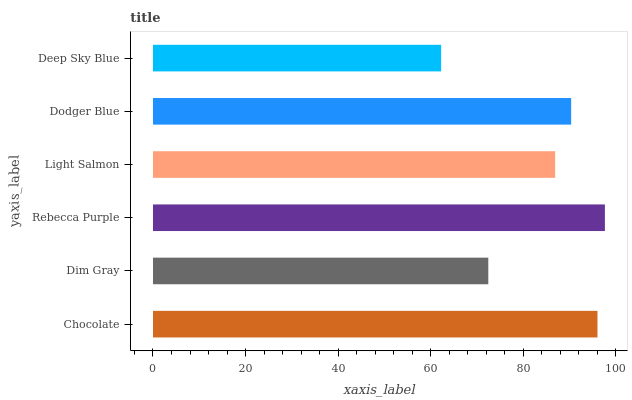Is Deep Sky Blue the minimum?
Answer yes or no. Yes. Is Rebecca Purple the maximum?
Answer yes or no. Yes. Is Dim Gray the minimum?
Answer yes or no. No. Is Dim Gray the maximum?
Answer yes or no. No. Is Chocolate greater than Dim Gray?
Answer yes or no. Yes. Is Dim Gray less than Chocolate?
Answer yes or no. Yes. Is Dim Gray greater than Chocolate?
Answer yes or no. No. Is Chocolate less than Dim Gray?
Answer yes or no. No. Is Dodger Blue the high median?
Answer yes or no. Yes. Is Light Salmon the low median?
Answer yes or no. Yes. Is Light Salmon the high median?
Answer yes or no. No. Is Deep Sky Blue the low median?
Answer yes or no. No. 